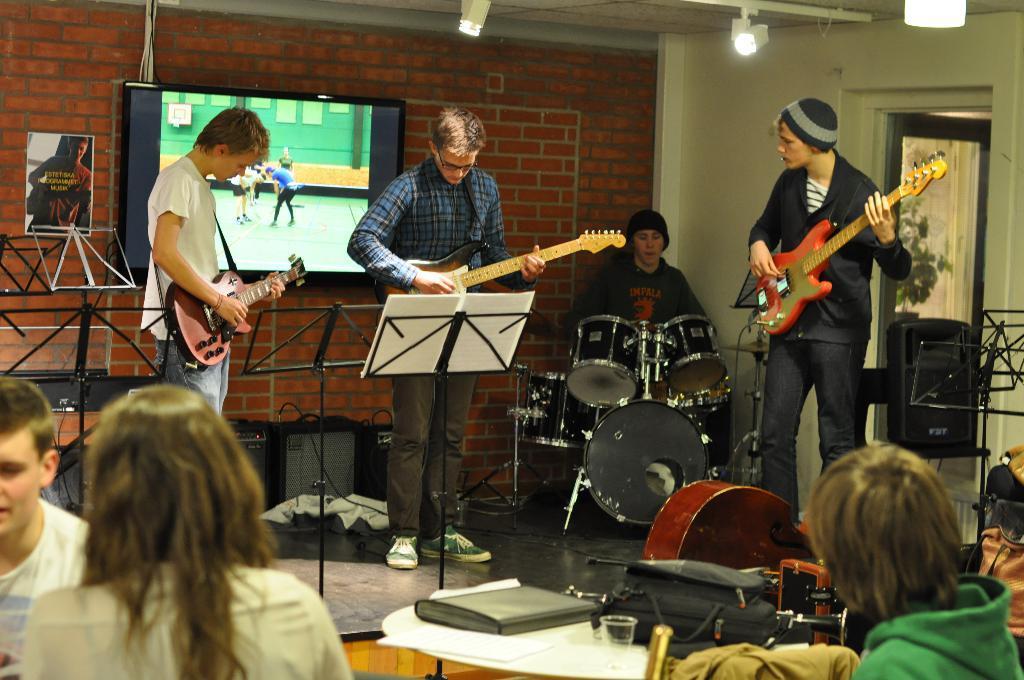How would you summarize this image in a sentence or two? These three persons standing and holding guitar. This person sitting and playing musical instrument. These persons sitting. We can see glass,book. This is floor. On the background we can see wall. television. 